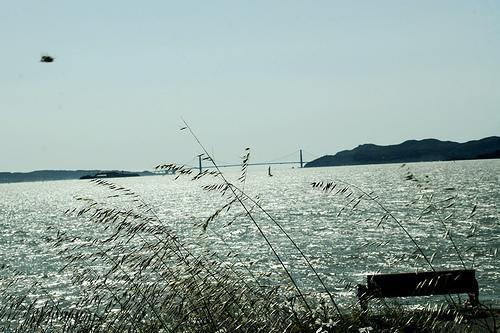How many people are on the bench?
Give a very brief answer. 0. How many park benches have been flooded?
Give a very brief answer. 1. How many chairs are there?
Give a very brief answer. 1. 